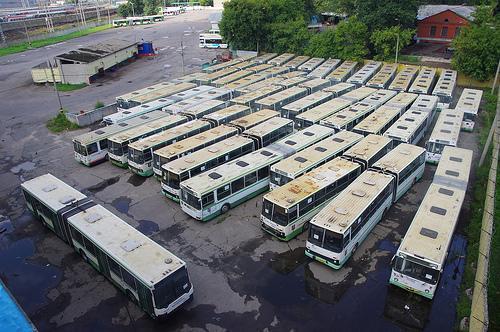How many dogs are in the photo?
Give a very brief answer. 0. 